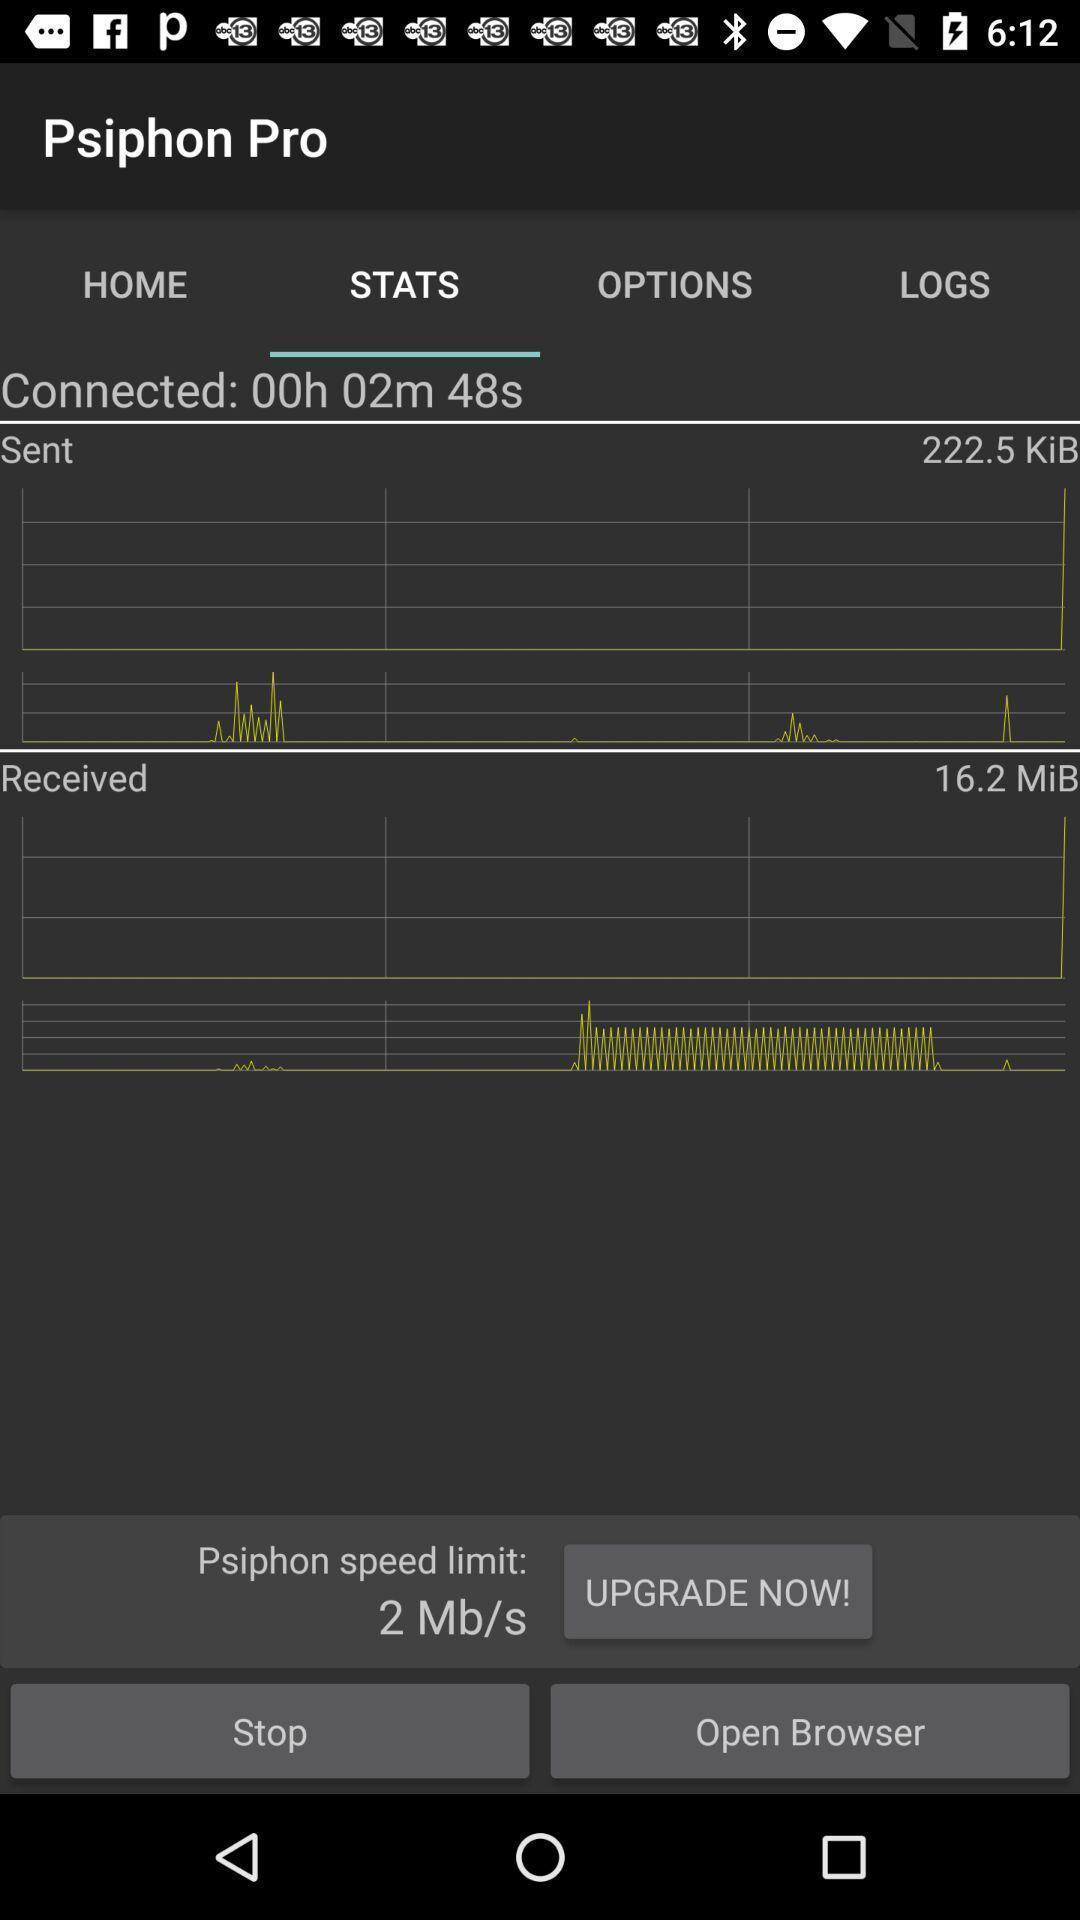Tell me what you see in this picture. Stats information page of a news app. 